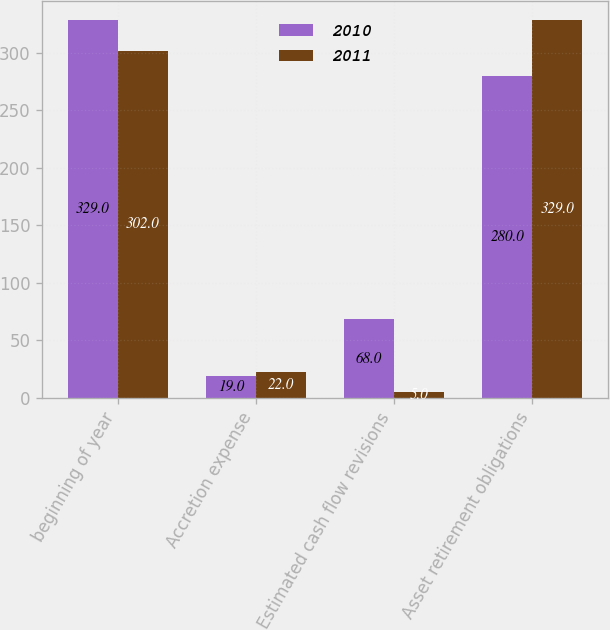Convert chart to OTSL. <chart><loc_0><loc_0><loc_500><loc_500><stacked_bar_chart><ecel><fcel>beginning of year<fcel>Accretion expense<fcel>Estimated cash flow revisions<fcel>Asset retirement obligations<nl><fcel>2010<fcel>329<fcel>19<fcel>68<fcel>280<nl><fcel>2011<fcel>302<fcel>22<fcel>5<fcel>329<nl></chart> 